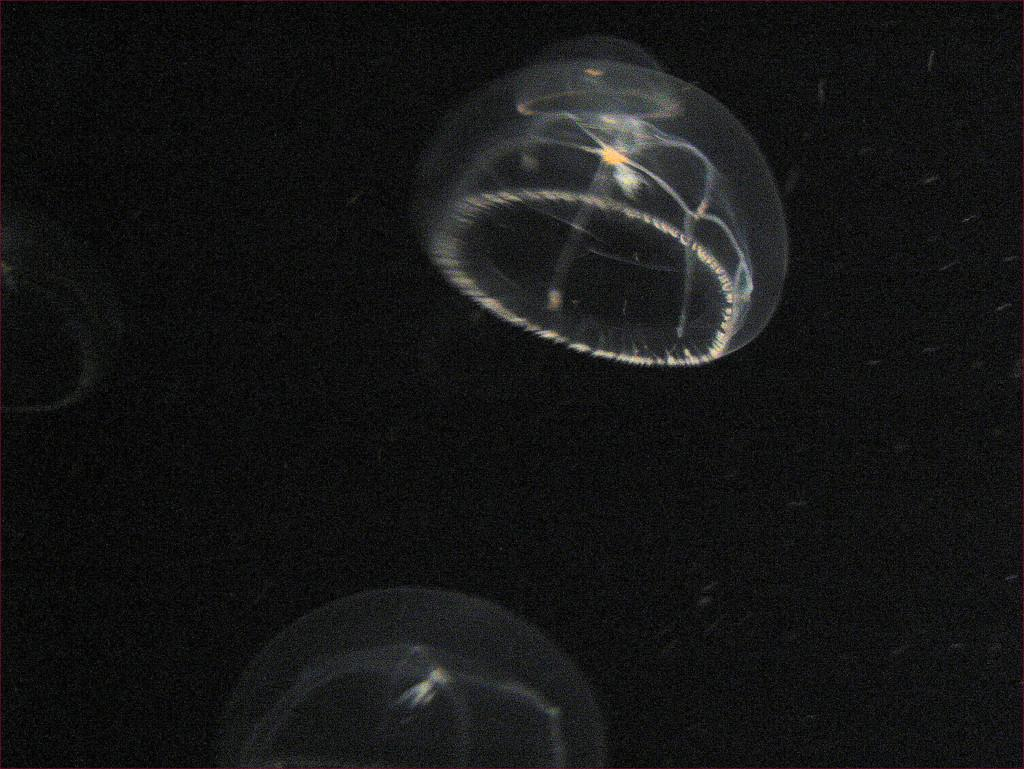How many objects are present in the image? There are three similar objects in the image. What are the objects made of? The objects are made of glass. What is the value of the beetle in the image? There is no beetle present in the image; the objects are made of glass. 